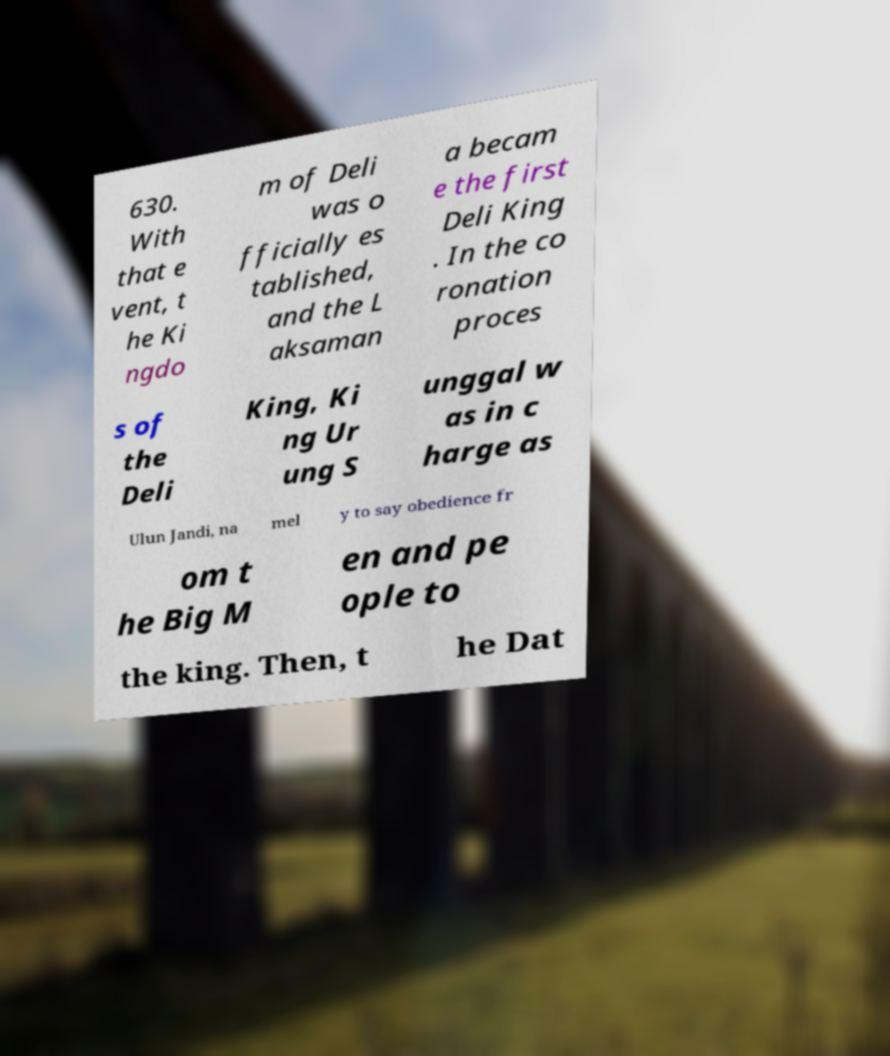Can you read and provide the text displayed in the image?This photo seems to have some interesting text. Can you extract and type it out for me? 630. With that e vent, t he Ki ngdo m of Deli was o fficially es tablished, and the L aksaman a becam e the first Deli King . In the co ronation proces s of the Deli King, Ki ng Ur ung S unggal w as in c harge as Ulun Jandi, na mel y to say obedience fr om t he Big M en and pe ople to the king. Then, t he Dat 